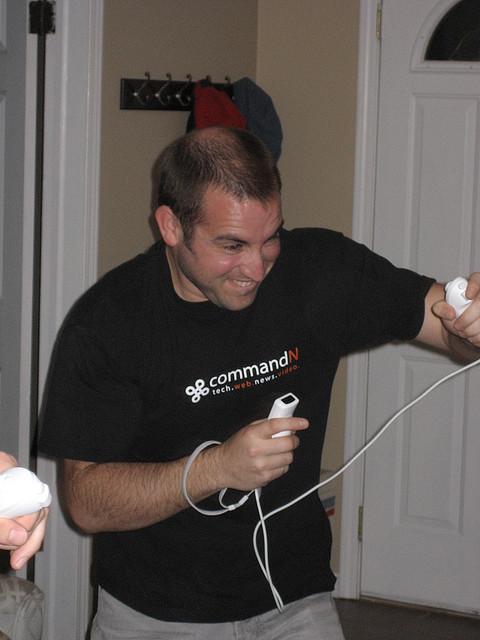Is this man playing a game?
Concise answer only. Yes. What color is the man's shirt?
Concise answer only. Black. Is there a coat rack?
Short answer required. Yes. 